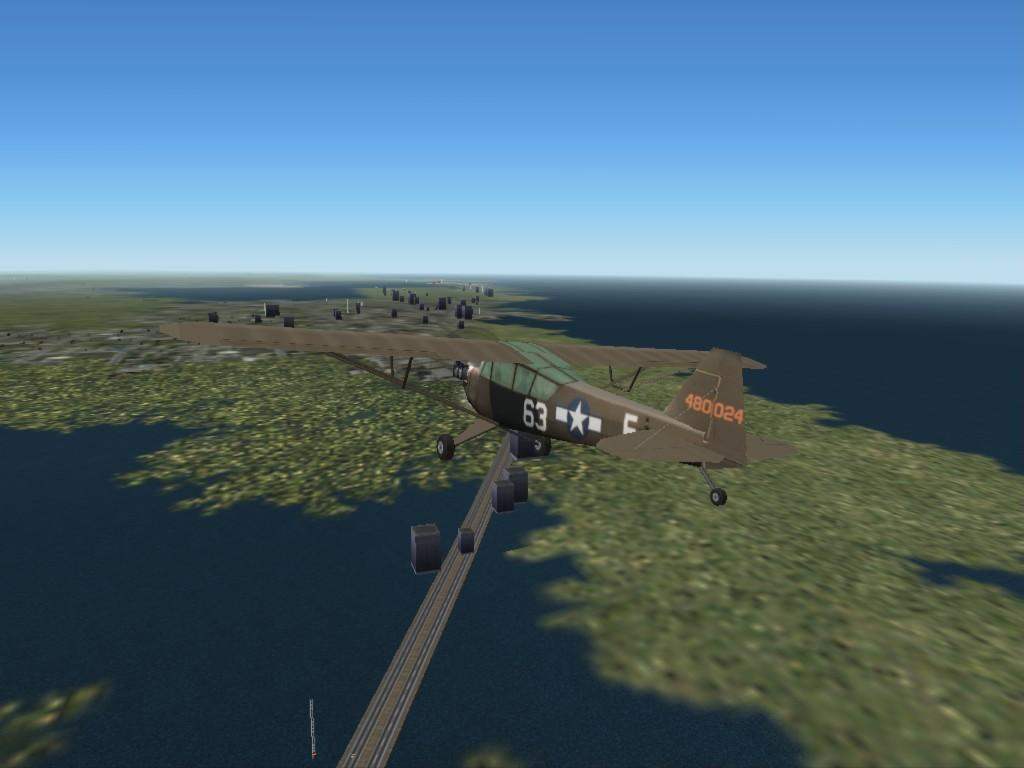<image>
Render a clear and concise summary of the photo. computer animation of plane number 63 and on tail it has 480024 